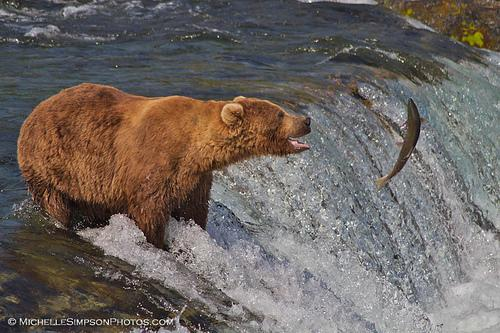Question: what is this bear doing?
Choices:
A. Scratching it's back.
B. Hibernating.
C. Catching a fish.
D. Raiding a trashcan.
Answer with the letter. Answer: C Question: what color is the bear?
Choices:
A. Black.
B. Red.
C. Brown.
D. White.
Answer with the letter. Answer: C Question: how many fish do you see?
Choices:
A. 2.
B. 5.
C. 1.
D. 3.
Answer with the letter. Answer: C Question: why is the fish in the air?
Choices:
A. It is spawning.
B. It is swimming upstream.
C. Catching a bug.
D. Spitting out the bait.
Answer with the letter. Answer: B Question: what color is the leaf in the upper corner?
Choices:
A. Green.
B. Red.
C. Orange.
D. Yellow.
Answer with the letter. Answer: A Question: how many bears are catching fish?
Choices:
A. 2.
B. 3.
C. 1.
D. 4.
Answer with the letter. Answer: C 